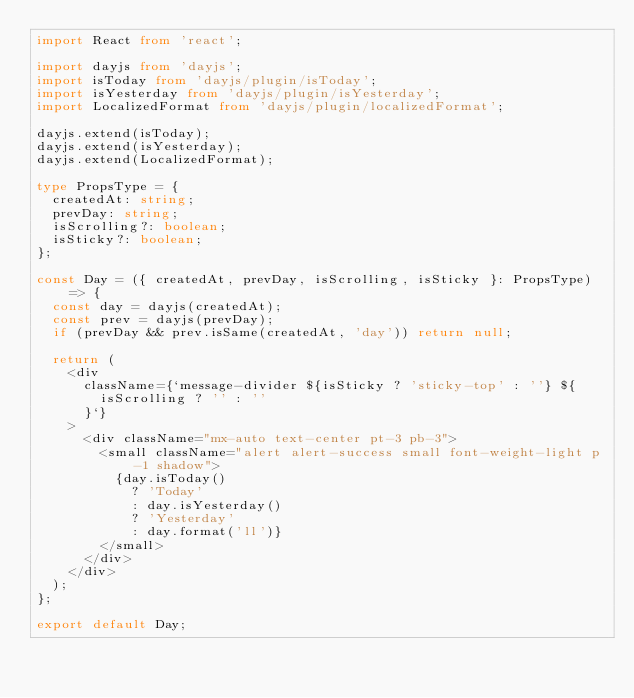<code> <loc_0><loc_0><loc_500><loc_500><_TypeScript_>import React from 'react';

import dayjs from 'dayjs';
import isToday from 'dayjs/plugin/isToday';
import isYesterday from 'dayjs/plugin/isYesterday';
import LocalizedFormat from 'dayjs/plugin/localizedFormat';

dayjs.extend(isToday);
dayjs.extend(isYesterday);
dayjs.extend(LocalizedFormat);

type PropsType = {
  createdAt: string;
  prevDay: string;
  isScrolling?: boolean;
  isSticky?: boolean;
};

const Day = ({ createdAt, prevDay, isScrolling, isSticky }: PropsType) => {
  const day = dayjs(createdAt);
  const prev = dayjs(prevDay);
  if (prevDay && prev.isSame(createdAt, 'day')) return null;

  return (
    <div
      className={`message-divider ${isSticky ? 'sticky-top' : ''} ${
        isScrolling ? '' : ''
      }`}
    >
      <div className="mx-auto text-center pt-3 pb-3">
        <small className="alert alert-success small font-weight-light p-1 shadow">
          {day.isToday()
            ? 'Today'
            : day.isYesterday()
            ? 'Yesterday'
            : day.format('ll')}
        </small>
      </div>
    </div>
  );
};

export default Day;
</code> 